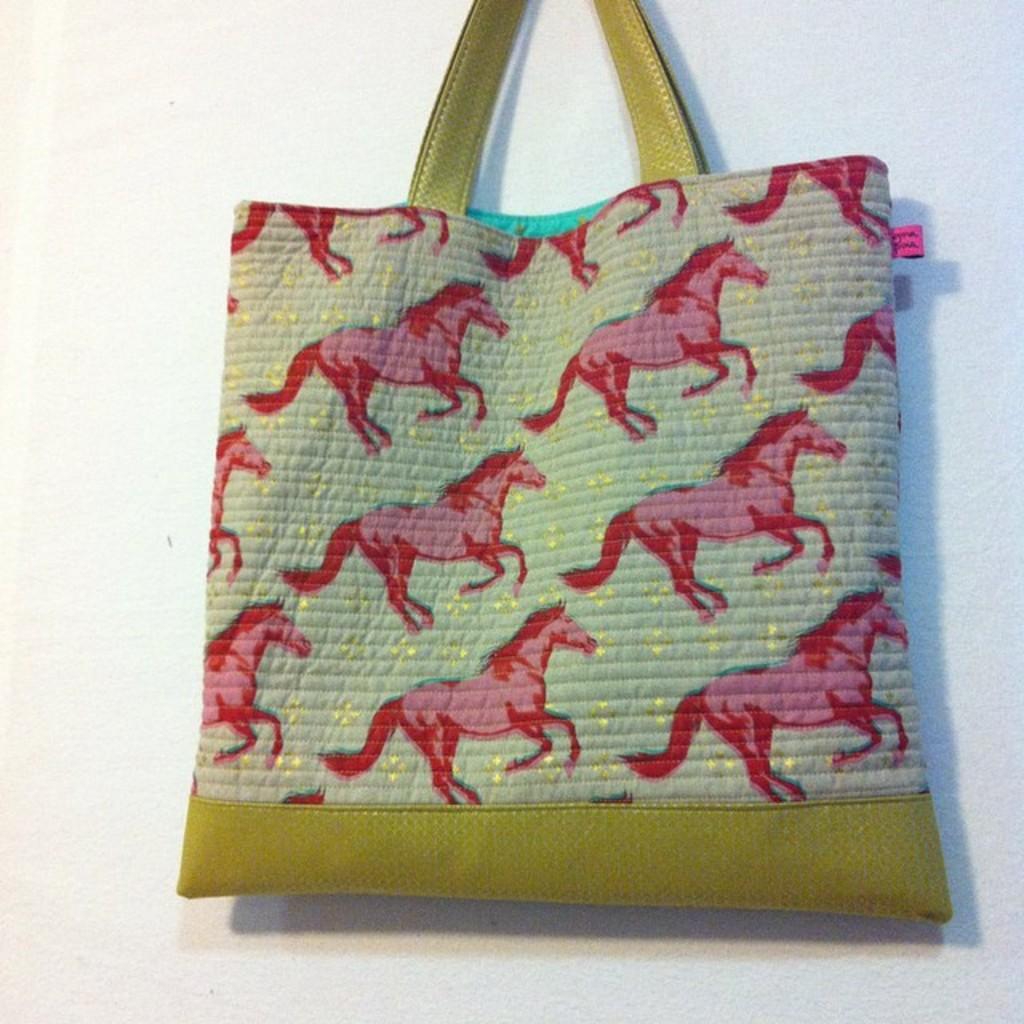Please provide a concise description of this image. There are horse pictures on a handbag. 